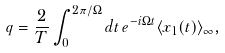<formula> <loc_0><loc_0><loc_500><loc_500>q = \frac { 2 } { T } \int _ { 0 } ^ { 2 \pi / \Omega } d t \, e ^ { - i \Omega t } \langle x _ { 1 } ( t ) \rangle _ { \infty } ,</formula> 